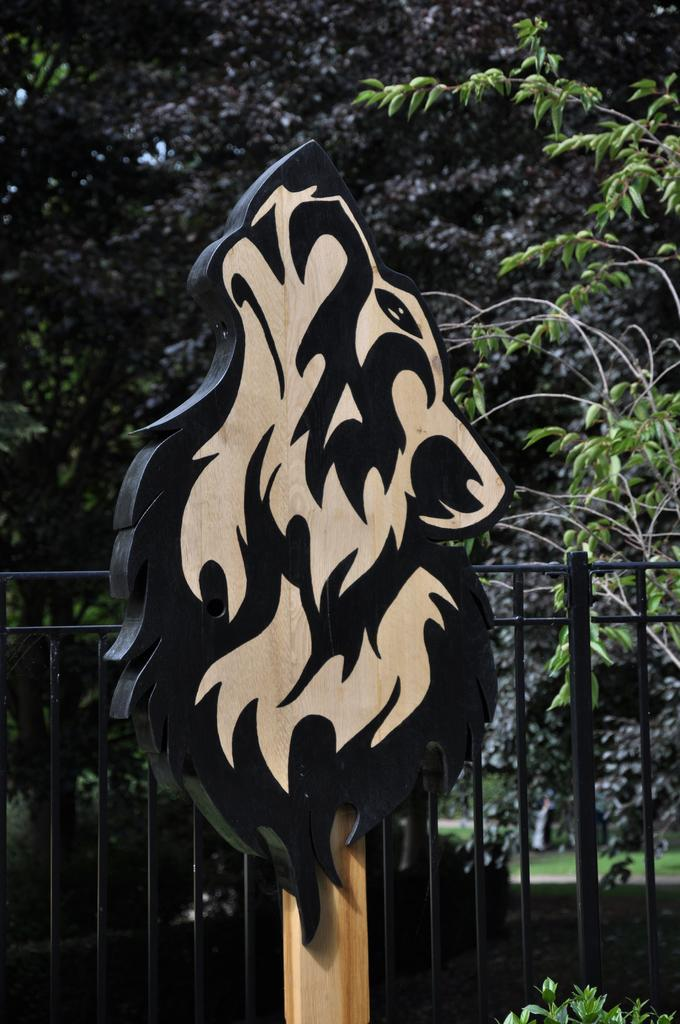What type of vegetation can be seen in the image? There are trees in the image. What material is the fence made of in the image? There is a metal fence in the image. What type of artwork is present in the image? There is a painting on a wooden surface in the image. Can you describe the mist in the image? There is no mist present in the image. What type of bird can be seen flying in the sky in the image? There is no bird or sky visible in the image; it only features trees, a metal fence, and a painting on a wooden surface. 